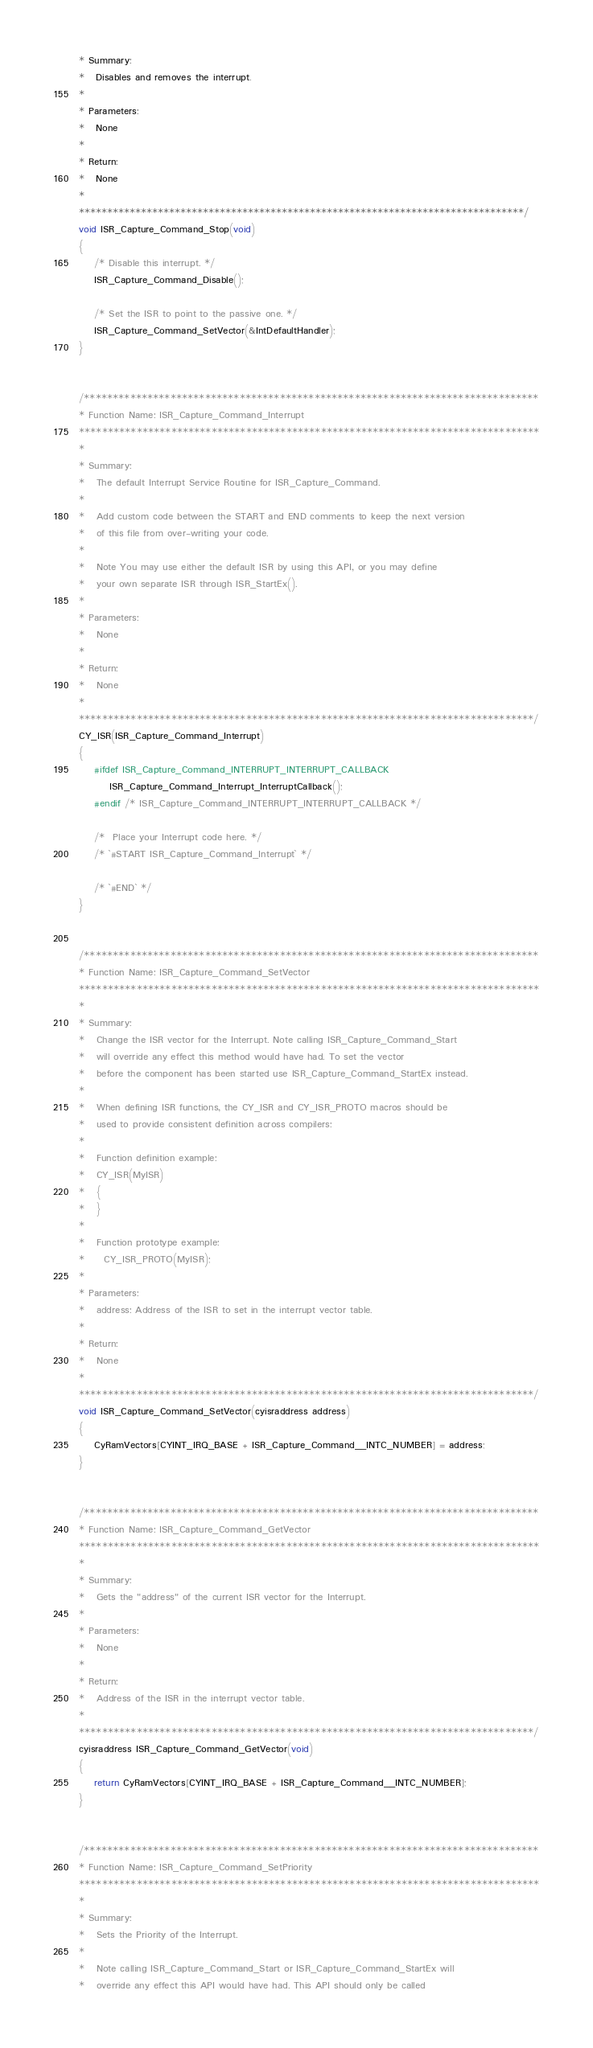Convert code to text. <code><loc_0><loc_0><loc_500><loc_500><_C_>* Summary:
*   Disables and removes the interrupt.
*
* Parameters:  
*   None
*
* Return:
*   None
*
*******************************************************************************/
void ISR_Capture_Command_Stop(void)
{
    /* Disable this interrupt. */
    ISR_Capture_Command_Disable();

    /* Set the ISR to point to the passive one. */
    ISR_Capture_Command_SetVector(&IntDefaultHandler);
}


/*******************************************************************************
* Function Name: ISR_Capture_Command_Interrupt
********************************************************************************
*
* Summary:
*   The default Interrupt Service Routine for ISR_Capture_Command.
*
*   Add custom code between the START and END comments to keep the next version
*   of this file from over-writing your code.
*
*   Note You may use either the default ISR by using this API, or you may define
*   your own separate ISR through ISR_StartEx().
*
* Parameters:  
*   None
*
* Return:
*   None
*
*******************************************************************************/
CY_ISR(ISR_Capture_Command_Interrupt)
{
    #ifdef ISR_Capture_Command_INTERRUPT_INTERRUPT_CALLBACK
        ISR_Capture_Command_Interrupt_InterruptCallback();
    #endif /* ISR_Capture_Command_INTERRUPT_INTERRUPT_CALLBACK */ 

    /*  Place your Interrupt code here. */
    /* `#START ISR_Capture_Command_Interrupt` */

    /* `#END` */
}


/*******************************************************************************
* Function Name: ISR_Capture_Command_SetVector
********************************************************************************
*
* Summary:
*   Change the ISR vector for the Interrupt. Note calling ISR_Capture_Command_Start
*   will override any effect this method would have had. To set the vector 
*   before the component has been started use ISR_Capture_Command_StartEx instead.
* 
*   When defining ISR functions, the CY_ISR and CY_ISR_PROTO macros should be 
*   used to provide consistent definition across compilers:
*
*   Function definition example:
*   CY_ISR(MyISR)
*   {
*   }
*
*   Function prototype example:
*     CY_ISR_PROTO(MyISR);
*
* Parameters:
*   address: Address of the ISR to set in the interrupt vector table.
*
* Return:
*   None
*
*******************************************************************************/
void ISR_Capture_Command_SetVector(cyisraddress address)
{
    CyRamVectors[CYINT_IRQ_BASE + ISR_Capture_Command__INTC_NUMBER] = address;
}


/*******************************************************************************
* Function Name: ISR_Capture_Command_GetVector
********************************************************************************
*
* Summary:
*   Gets the "address" of the current ISR vector for the Interrupt.
*
* Parameters:
*   None
*
* Return:
*   Address of the ISR in the interrupt vector table.
*
*******************************************************************************/
cyisraddress ISR_Capture_Command_GetVector(void)
{
    return CyRamVectors[CYINT_IRQ_BASE + ISR_Capture_Command__INTC_NUMBER];
}


/*******************************************************************************
* Function Name: ISR_Capture_Command_SetPriority
********************************************************************************
*
* Summary:
*   Sets the Priority of the Interrupt. 
*
*   Note calling ISR_Capture_Command_Start or ISR_Capture_Command_StartEx will 
*   override any effect this API would have had. This API should only be called</code> 